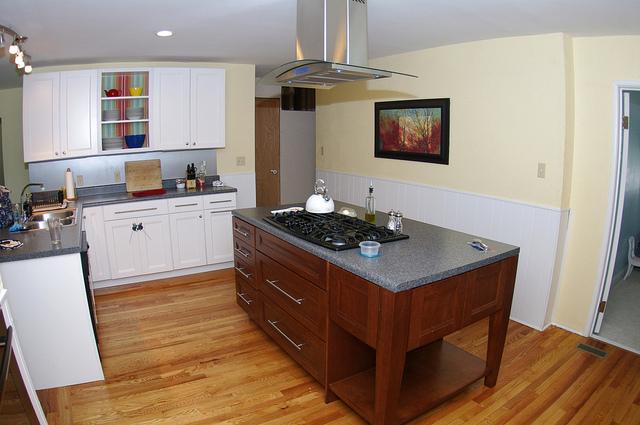What is in the blue cart?
Short answer required. Nothing. Is this kitchen tiny?
Short answer required. No. How many lights are in the kitchen?
Be succinct. 5. What color are the room's walls?
Short answer required. Yellow. Is there a picture above the sink?
Quick response, please. No. What is the sink for?
Concise answer only. Dishes. Does this kitchen appear to be under construction?
Answer briefly. No. What room is this?
Give a very brief answer. Kitchen. What color are the kitchen cabinets?
Short answer required. White. Is the kitchen floor tiled or hardwood?
Be succinct. Hardwood. 